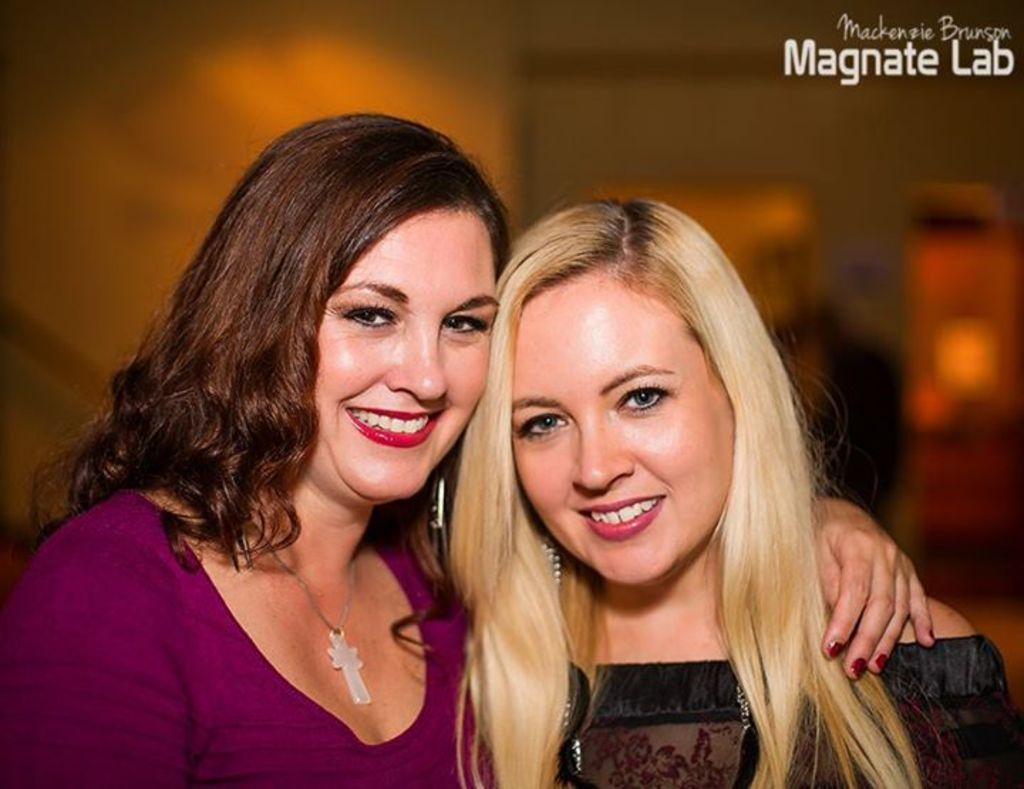How many people are in the image? There are two women in the image. Can you describe the background of the image? The background of the image is blurry. Is there any text visible in the image? Yes, there is some text visible in the top right corner of the image. What type of plant is the beggar holding in the image? There is no plant or beggar present in the image. 